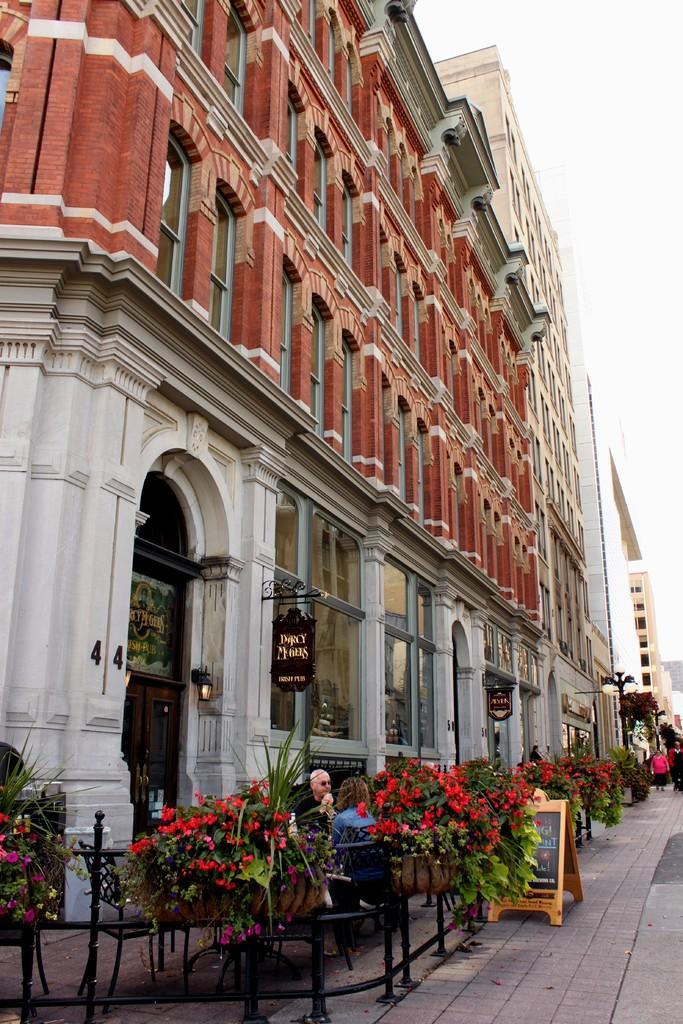Please provide a concise description of this image. In this image, we can see buildings, boards, glass objects, brick wall, door, wall, poles, people, rod railing, chairs and flower plants. Here we can see boards. On the right side of the image, we can see the sky and people are on the walkway. 